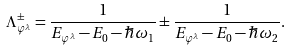Convert formula to latex. <formula><loc_0><loc_0><loc_500><loc_500>\Lambda _ { \varphi ^ { \lambda } } ^ { \pm } = \frac { 1 } { E _ { \varphi ^ { \lambda } } - E _ { 0 } - \hbar { \omega } _ { 1 } } \pm \frac { 1 } { E _ { \varphi ^ { \lambda } } - E _ { 0 } - \hbar { \omega } _ { 2 } } .</formula> 